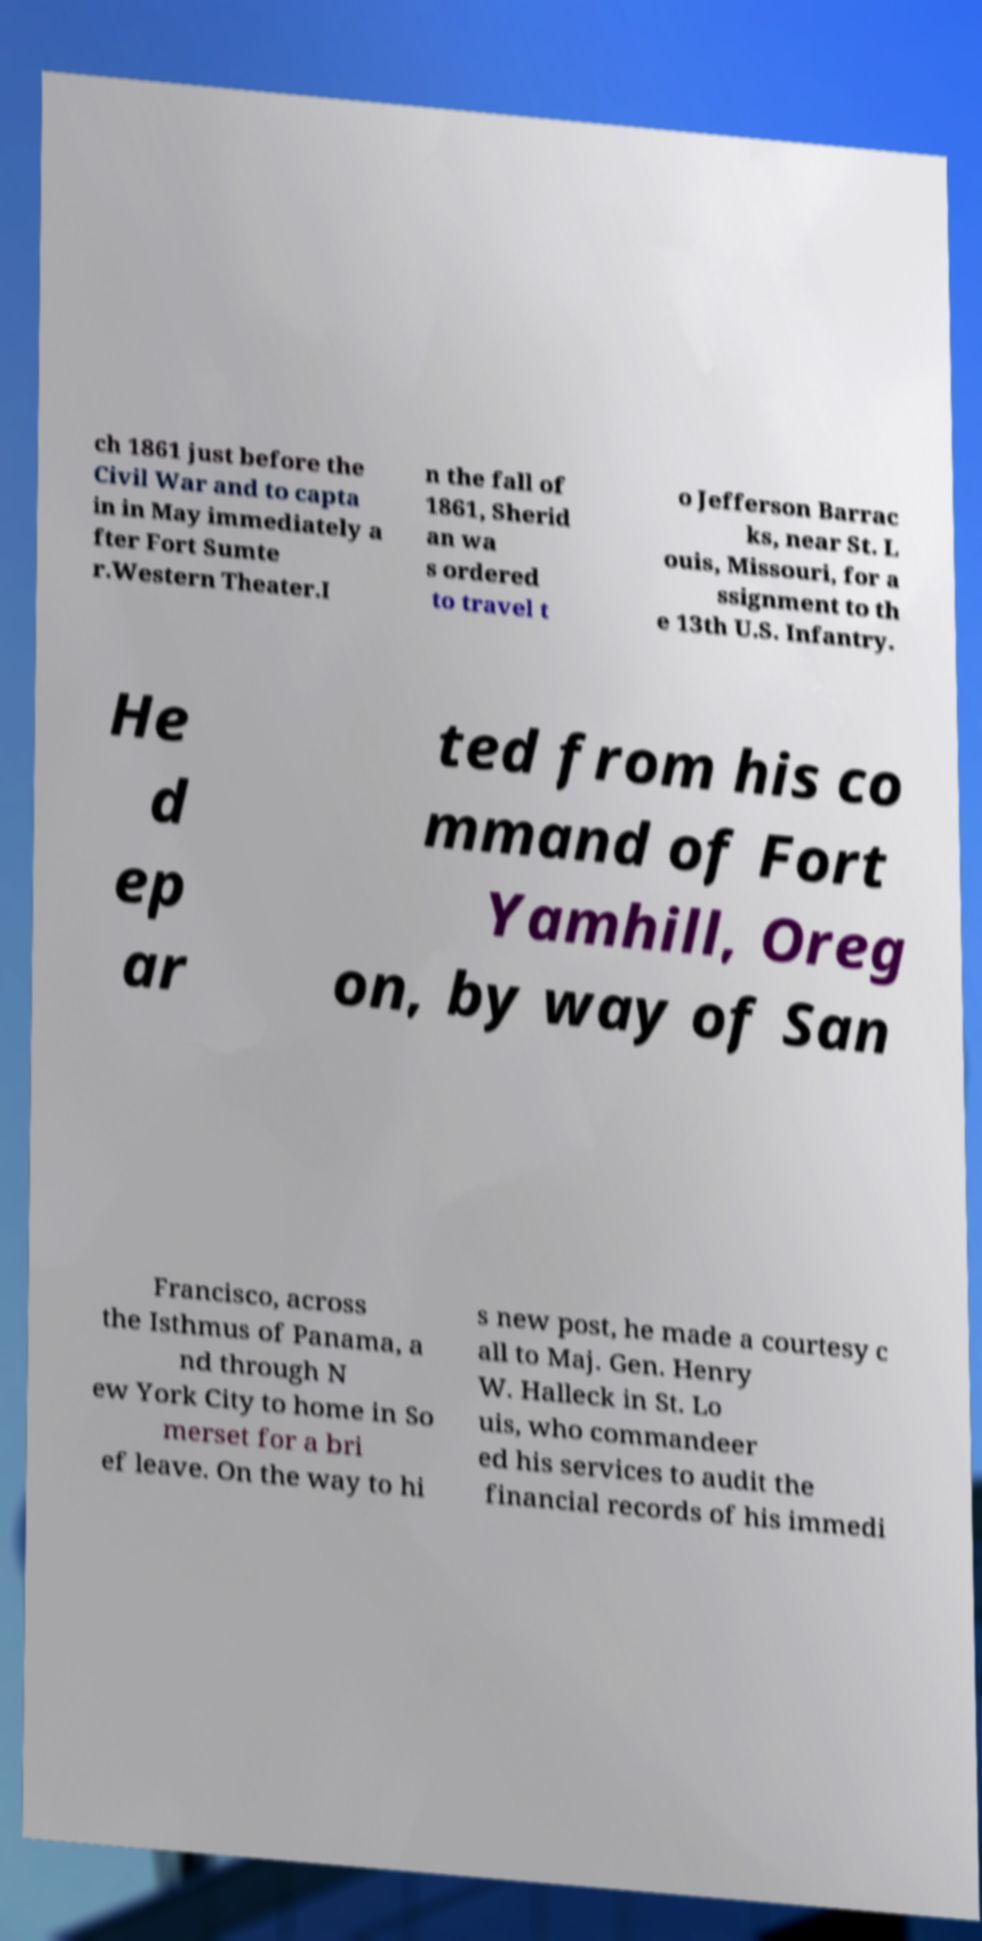I need the written content from this picture converted into text. Can you do that? ch 1861 just before the Civil War and to capta in in May immediately a fter Fort Sumte r.Western Theater.I n the fall of 1861, Sherid an wa s ordered to travel t o Jefferson Barrac ks, near St. L ouis, Missouri, for a ssignment to th e 13th U.S. Infantry. He d ep ar ted from his co mmand of Fort Yamhill, Oreg on, by way of San Francisco, across the Isthmus of Panama, a nd through N ew York City to home in So merset for a bri ef leave. On the way to hi s new post, he made a courtesy c all to Maj. Gen. Henry W. Halleck in St. Lo uis, who commandeer ed his services to audit the financial records of his immedi 